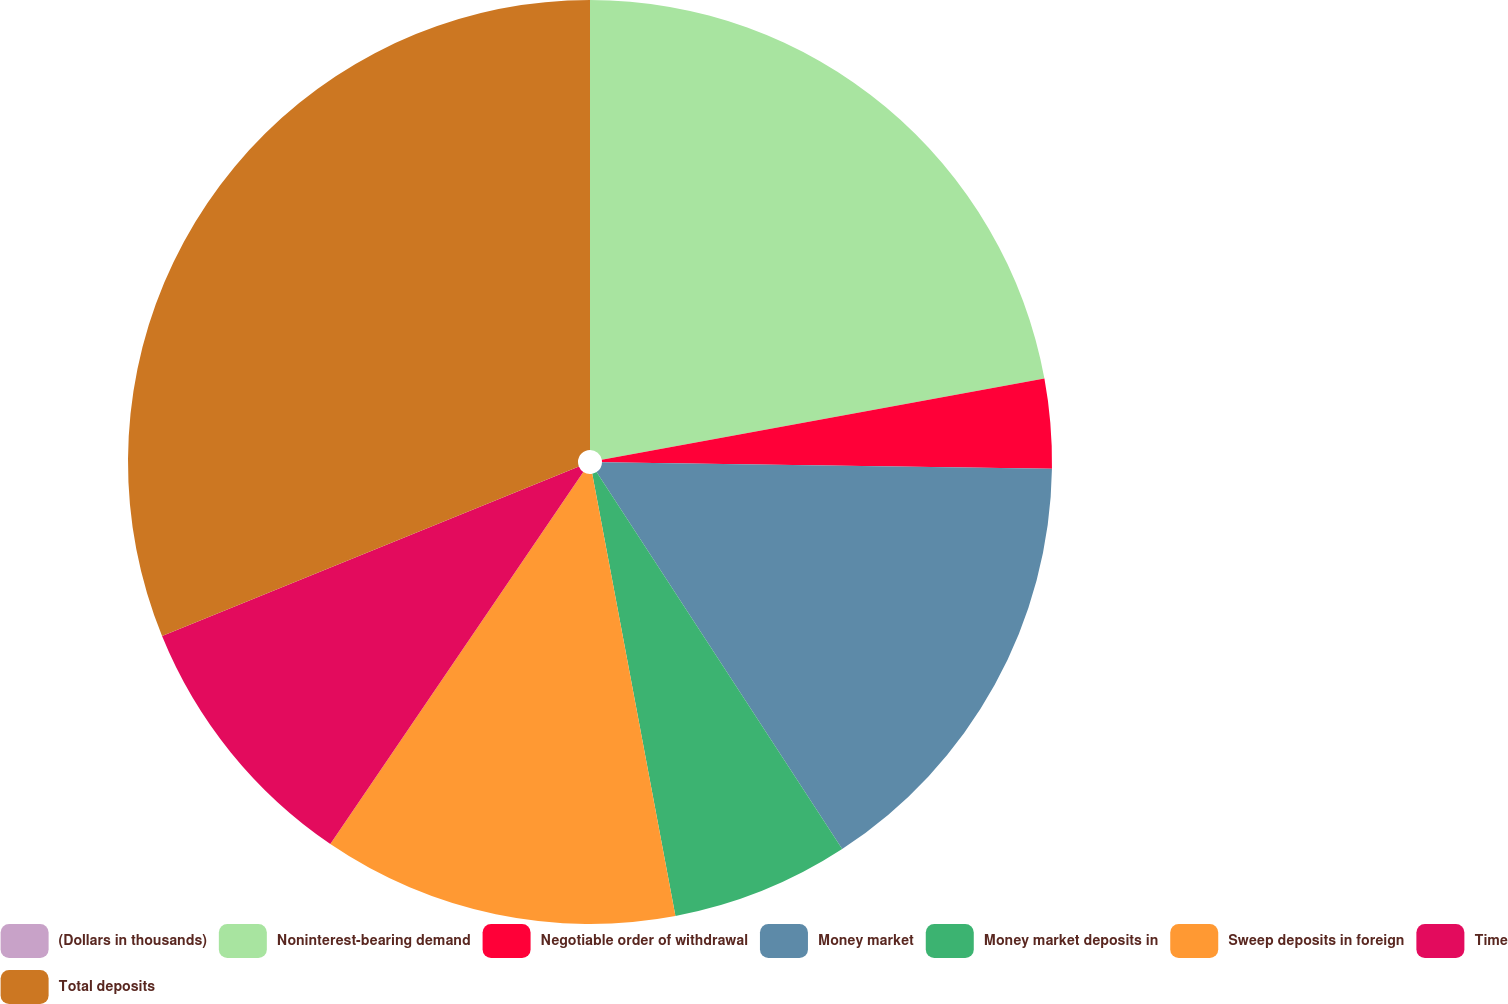Convert chart to OTSL. <chart><loc_0><loc_0><loc_500><loc_500><pie_chart><fcel>(Dollars in thousands)<fcel>Noninterest-bearing demand<fcel>Negotiable order of withdrawal<fcel>Money market<fcel>Money market deposits in<fcel>Sweep deposits in foreign<fcel>Time<fcel>Total deposits<nl><fcel>0.0%<fcel>22.11%<fcel>3.12%<fcel>15.58%<fcel>6.23%<fcel>12.46%<fcel>9.35%<fcel>31.15%<nl></chart> 